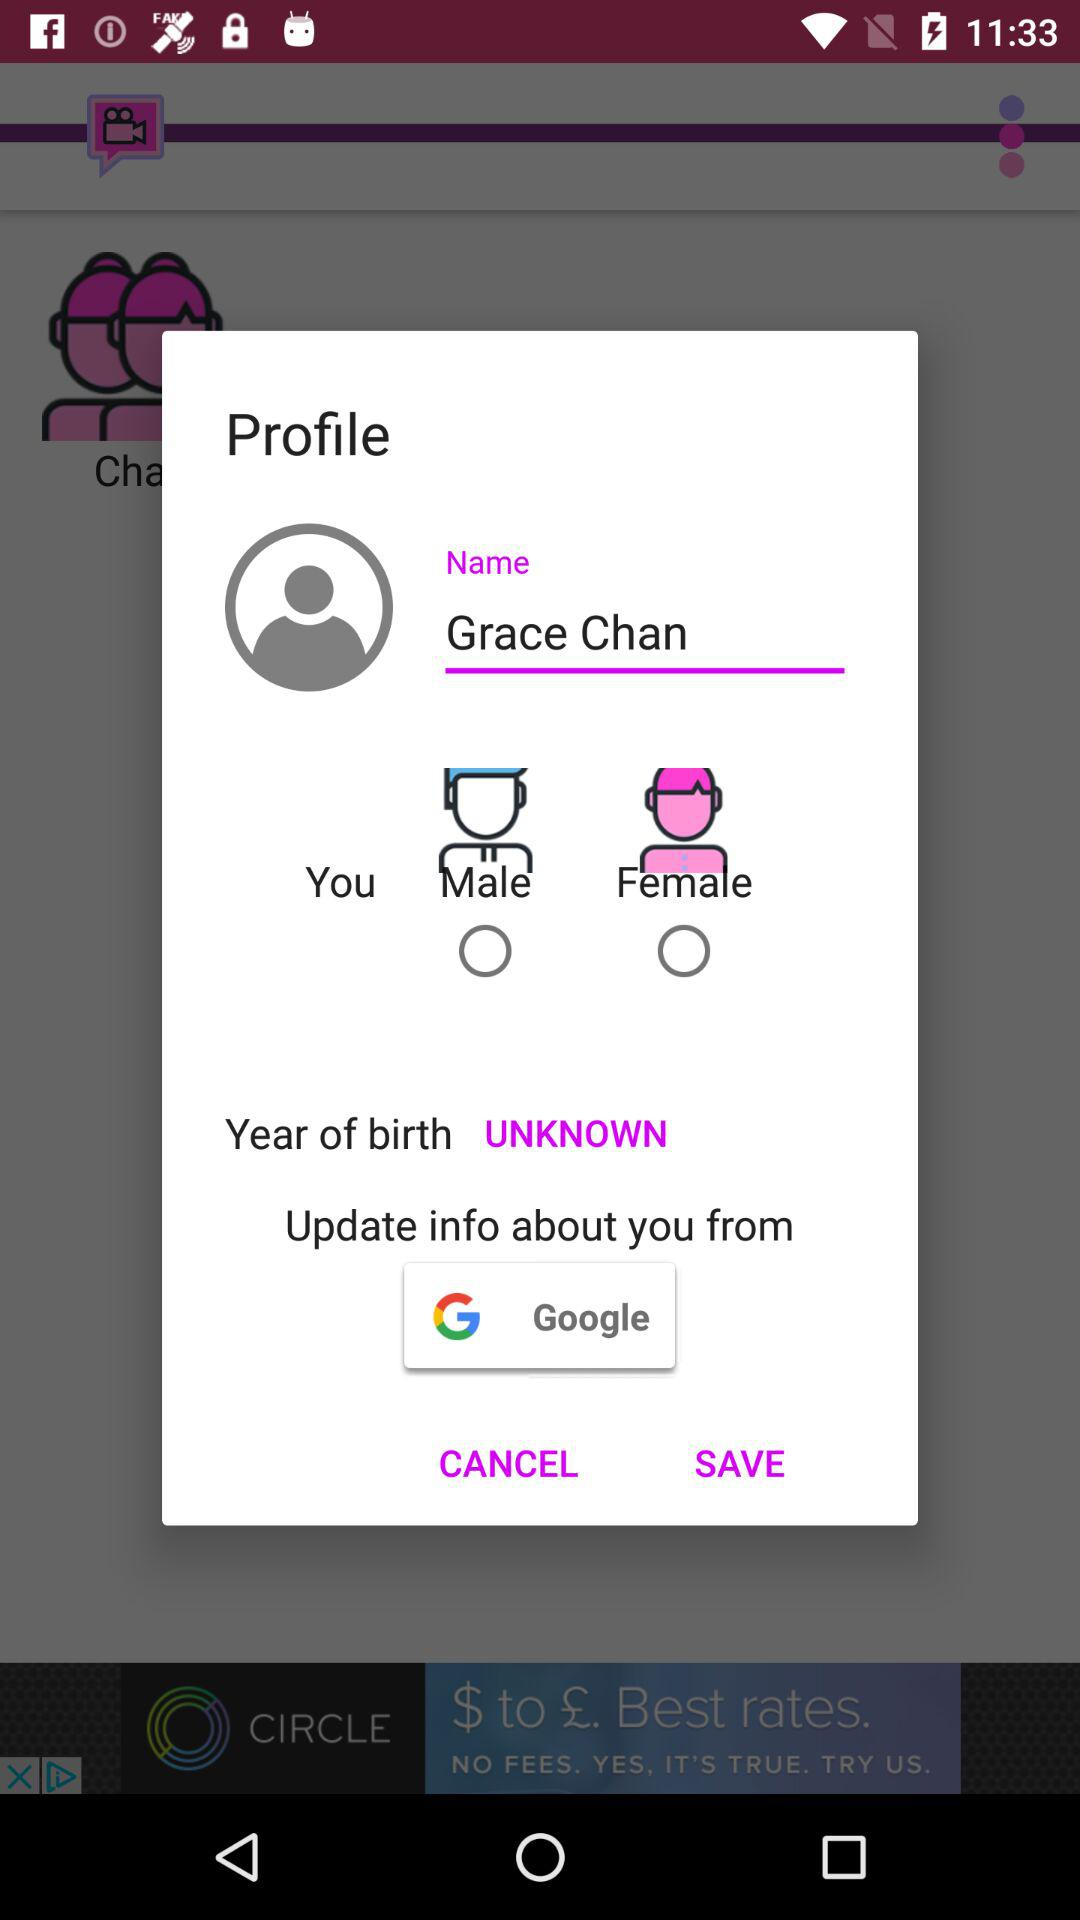What is the name of the profile? The name of the profile is Grace Chan. 